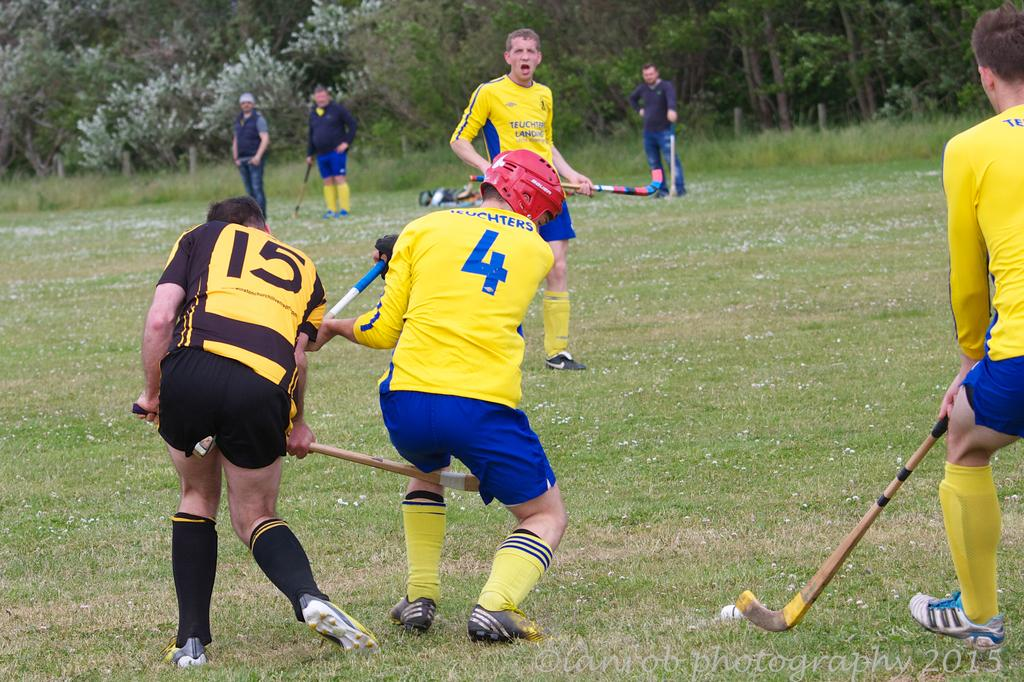<image>
Relay a brief, clear account of the picture shown. A rugby player wearing number four on the back of his jersey is fighting for the ball with the player from the other team, wearing number 15. 